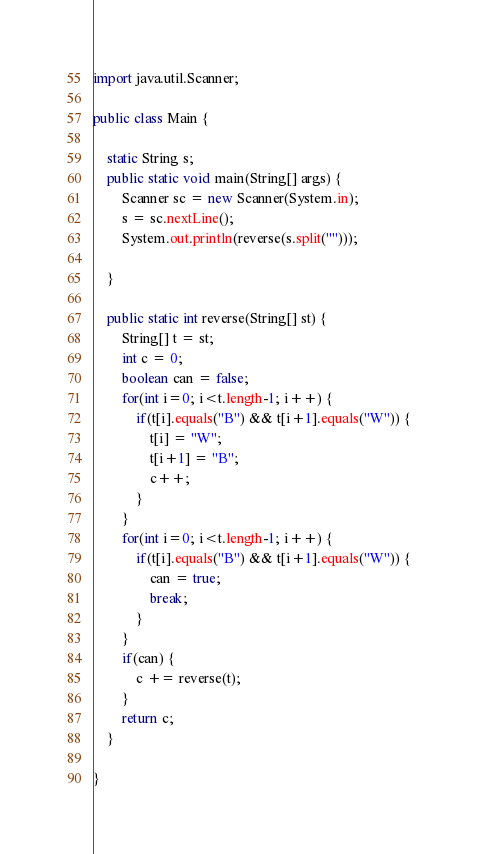Convert code to text. <code><loc_0><loc_0><loc_500><loc_500><_Java_>import java.util.Scanner;

public class Main {

	static String s;
	public static void main(String[] args) {
		Scanner sc = new Scanner(System.in);
		s = sc.nextLine();
		System.out.println(reverse(s.split("")));
		
	}
	
	public static int reverse(String[] st) {
		String[] t = st;
		int c = 0;
		boolean can = false;
		for(int i=0; i<t.length-1; i++) {
			if(t[i].equals("B") && t[i+1].equals("W")) {
				t[i] = "W";
				t[i+1] = "B";
				c++;
			}
		}
		for(int i=0; i<t.length-1; i++) {
			if(t[i].equals("B") && t[i+1].equals("W")) {
				can = true;
				break;
			}
		}
		if(can) {
			c += reverse(t);
		}
		return c;
	}

}
</code> 